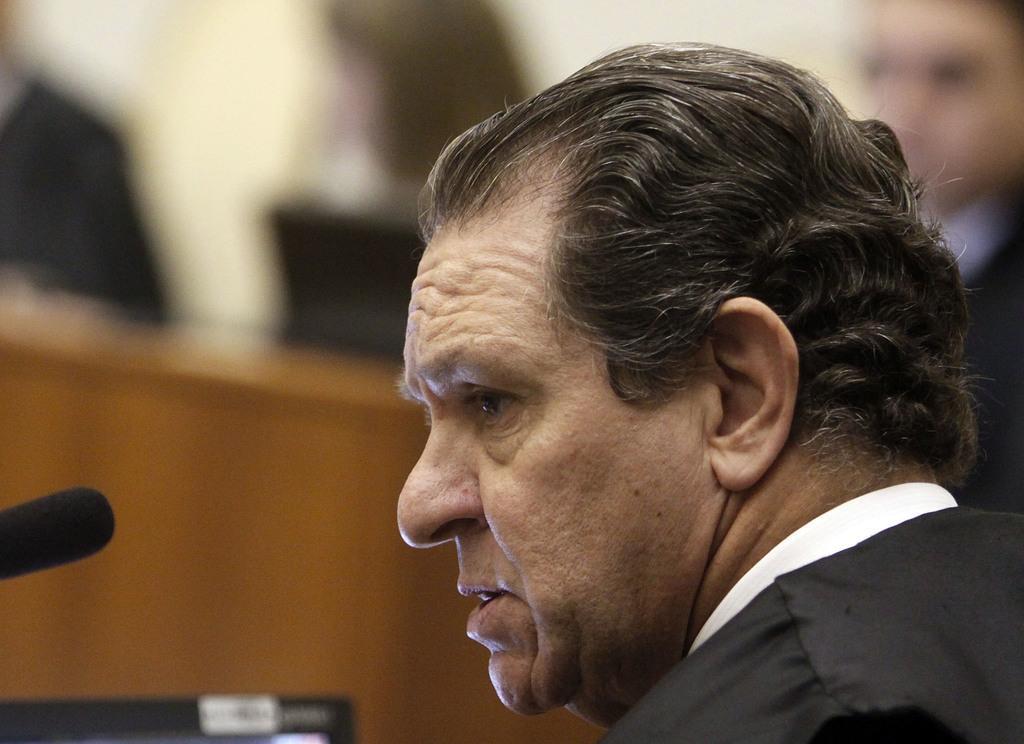Could you give a brief overview of what you see in this image? In this image in the foreground there is one person talking and there is a mike, at the bottom there is screen and there is a blurry background. 